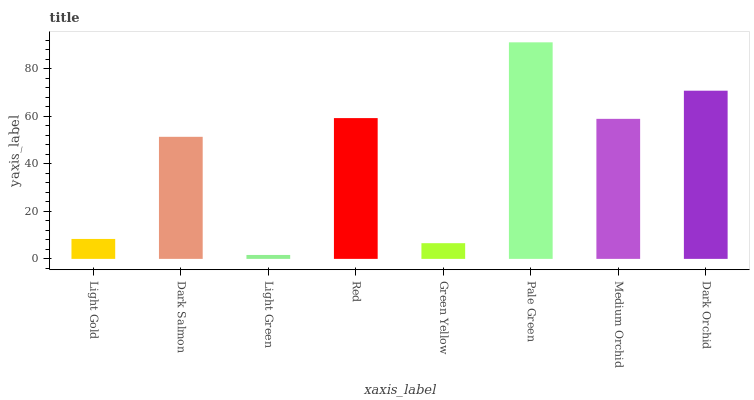Is Light Green the minimum?
Answer yes or no. Yes. Is Pale Green the maximum?
Answer yes or no. Yes. Is Dark Salmon the minimum?
Answer yes or no. No. Is Dark Salmon the maximum?
Answer yes or no. No. Is Dark Salmon greater than Light Gold?
Answer yes or no. Yes. Is Light Gold less than Dark Salmon?
Answer yes or no. Yes. Is Light Gold greater than Dark Salmon?
Answer yes or no. No. Is Dark Salmon less than Light Gold?
Answer yes or no. No. Is Medium Orchid the high median?
Answer yes or no. Yes. Is Dark Salmon the low median?
Answer yes or no. Yes. Is Dark Orchid the high median?
Answer yes or no. No. Is Green Yellow the low median?
Answer yes or no. No. 